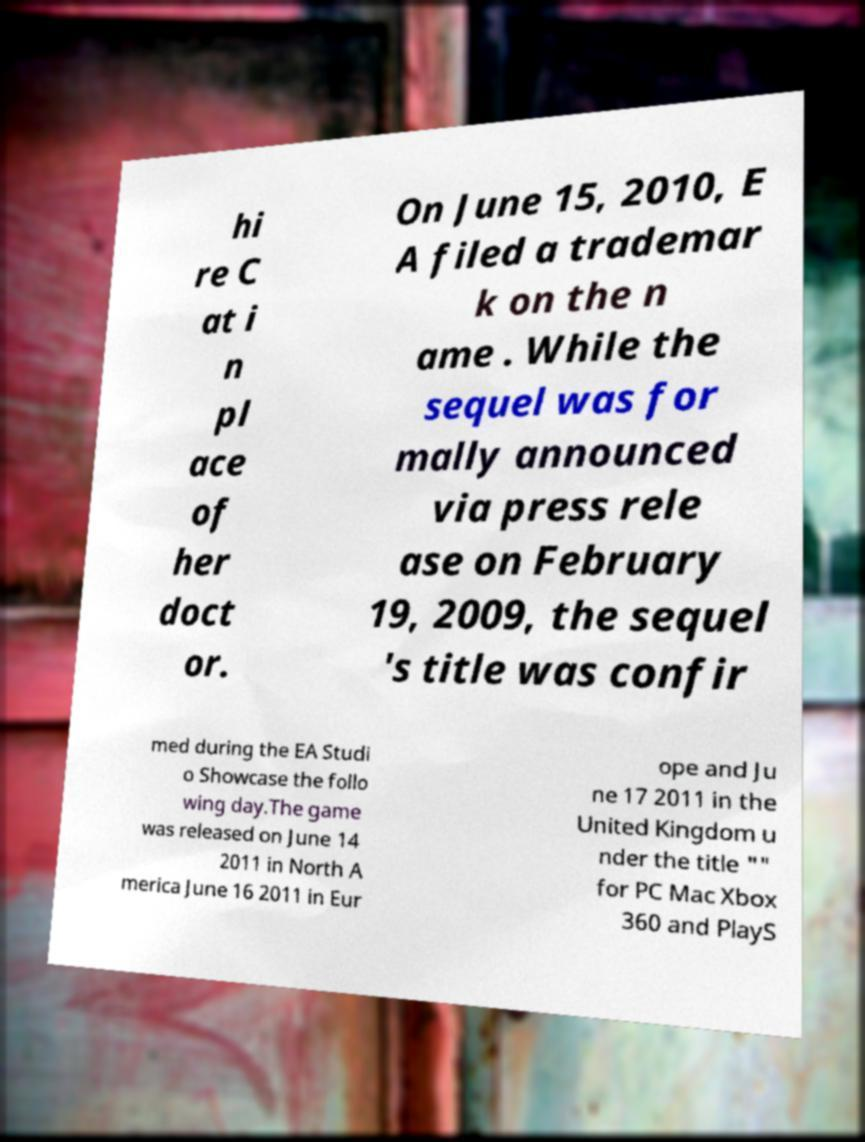Please identify and transcribe the text found in this image. hi re C at i n pl ace of her doct or. On June 15, 2010, E A filed a trademar k on the n ame . While the sequel was for mally announced via press rele ase on February 19, 2009, the sequel 's title was confir med during the EA Studi o Showcase the follo wing day.The game was released on June 14 2011 in North A merica June 16 2011 in Eur ope and Ju ne 17 2011 in the United Kingdom u nder the title "" for PC Mac Xbox 360 and PlayS 